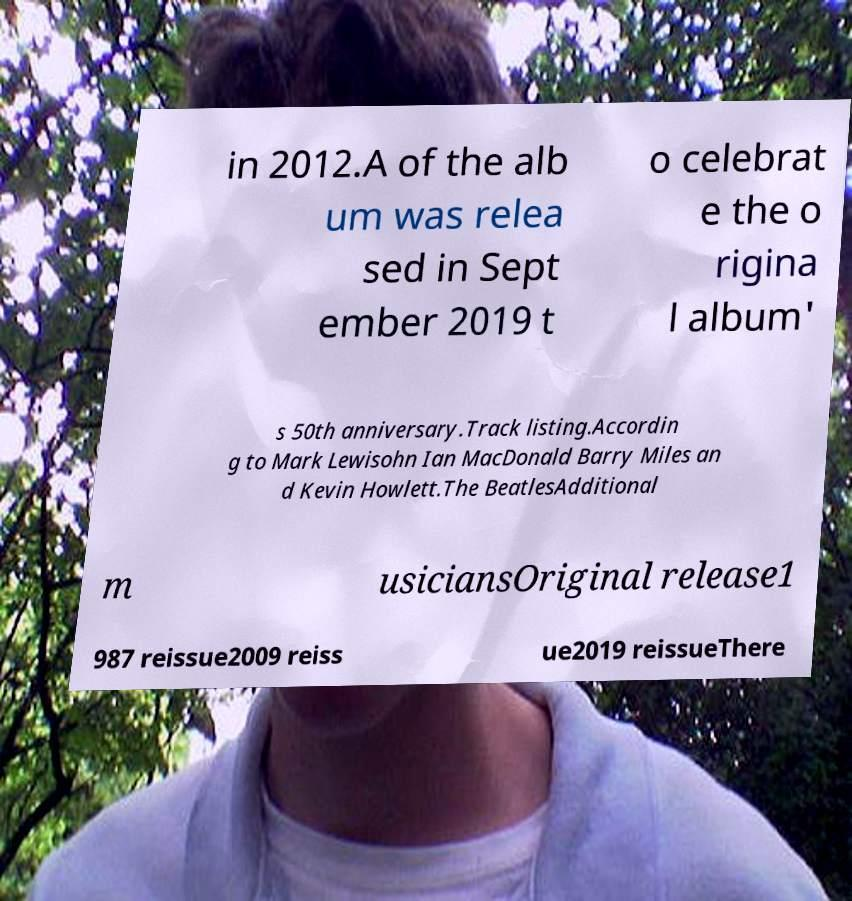Could you assist in decoding the text presented in this image and type it out clearly? in 2012.A of the alb um was relea sed in Sept ember 2019 t o celebrat e the o rigina l album' s 50th anniversary.Track listing.Accordin g to Mark Lewisohn Ian MacDonald Barry Miles an d Kevin Howlett.The BeatlesAdditional m usiciansOriginal release1 987 reissue2009 reiss ue2019 reissueThere 